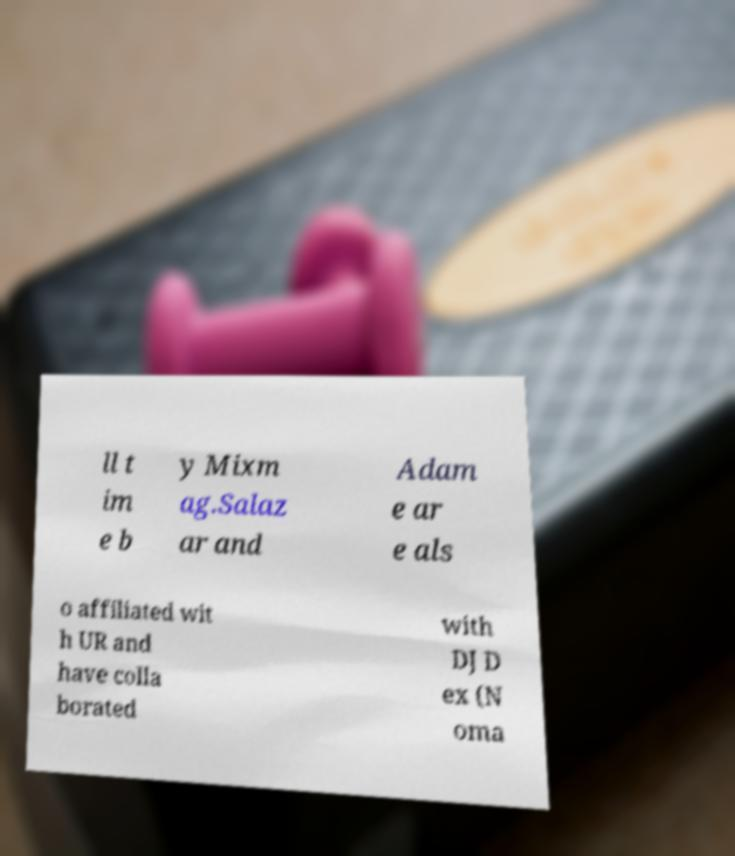Could you assist in decoding the text presented in this image and type it out clearly? ll t im e b y Mixm ag.Salaz ar and Adam e ar e als o affiliated wit h UR and have colla borated with DJ D ex (N oma 